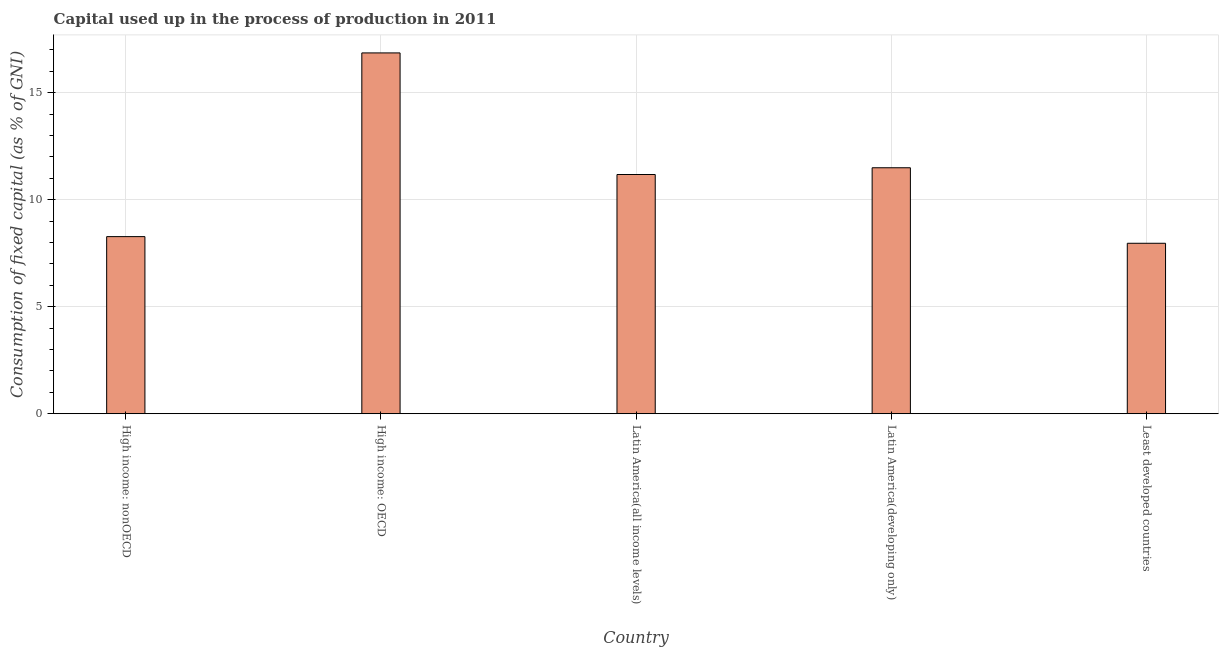Does the graph contain grids?
Ensure brevity in your answer.  Yes. What is the title of the graph?
Provide a succinct answer. Capital used up in the process of production in 2011. What is the label or title of the Y-axis?
Ensure brevity in your answer.  Consumption of fixed capital (as % of GNI). What is the consumption of fixed capital in High income: OECD?
Provide a succinct answer. 16.86. Across all countries, what is the maximum consumption of fixed capital?
Ensure brevity in your answer.  16.86. Across all countries, what is the minimum consumption of fixed capital?
Keep it short and to the point. 7.96. In which country was the consumption of fixed capital maximum?
Offer a terse response. High income: OECD. In which country was the consumption of fixed capital minimum?
Your answer should be very brief. Least developed countries. What is the sum of the consumption of fixed capital?
Your answer should be very brief. 55.77. What is the difference between the consumption of fixed capital in Latin America(all income levels) and Least developed countries?
Offer a very short reply. 3.21. What is the average consumption of fixed capital per country?
Offer a terse response. 11.15. What is the median consumption of fixed capital?
Ensure brevity in your answer.  11.18. What is the ratio of the consumption of fixed capital in High income: OECD to that in Latin America(all income levels)?
Give a very brief answer. 1.51. Is the consumption of fixed capital in High income: nonOECD less than that in Least developed countries?
Make the answer very short. No. Is the difference between the consumption of fixed capital in High income: nonOECD and Latin America(all income levels) greater than the difference between any two countries?
Provide a short and direct response. No. What is the difference between the highest and the second highest consumption of fixed capital?
Your response must be concise. 5.37. What is the difference between the highest and the lowest consumption of fixed capital?
Offer a terse response. 8.89. Are the values on the major ticks of Y-axis written in scientific E-notation?
Give a very brief answer. No. What is the Consumption of fixed capital (as % of GNI) of High income: nonOECD?
Offer a terse response. 8.28. What is the Consumption of fixed capital (as % of GNI) in High income: OECD?
Ensure brevity in your answer.  16.86. What is the Consumption of fixed capital (as % of GNI) in Latin America(all income levels)?
Offer a terse response. 11.18. What is the Consumption of fixed capital (as % of GNI) of Latin America(developing only)?
Offer a terse response. 11.49. What is the Consumption of fixed capital (as % of GNI) of Least developed countries?
Your response must be concise. 7.96. What is the difference between the Consumption of fixed capital (as % of GNI) in High income: nonOECD and High income: OECD?
Provide a short and direct response. -8.58. What is the difference between the Consumption of fixed capital (as % of GNI) in High income: nonOECD and Latin America(all income levels)?
Your answer should be compact. -2.9. What is the difference between the Consumption of fixed capital (as % of GNI) in High income: nonOECD and Latin America(developing only)?
Make the answer very short. -3.22. What is the difference between the Consumption of fixed capital (as % of GNI) in High income: nonOECD and Least developed countries?
Your response must be concise. 0.31. What is the difference between the Consumption of fixed capital (as % of GNI) in High income: OECD and Latin America(all income levels)?
Offer a very short reply. 5.68. What is the difference between the Consumption of fixed capital (as % of GNI) in High income: OECD and Latin America(developing only)?
Make the answer very short. 5.37. What is the difference between the Consumption of fixed capital (as % of GNI) in High income: OECD and Least developed countries?
Offer a very short reply. 8.89. What is the difference between the Consumption of fixed capital (as % of GNI) in Latin America(all income levels) and Latin America(developing only)?
Provide a short and direct response. -0.32. What is the difference between the Consumption of fixed capital (as % of GNI) in Latin America(all income levels) and Least developed countries?
Give a very brief answer. 3.21. What is the difference between the Consumption of fixed capital (as % of GNI) in Latin America(developing only) and Least developed countries?
Your answer should be compact. 3.53. What is the ratio of the Consumption of fixed capital (as % of GNI) in High income: nonOECD to that in High income: OECD?
Provide a succinct answer. 0.49. What is the ratio of the Consumption of fixed capital (as % of GNI) in High income: nonOECD to that in Latin America(all income levels)?
Provide a succinct answer. 0.74. What is the ratio of the Consumption of fixed capital (as % of GNI) in High income: nonOECD to that in Latin America(developing only)?
Give a very brief answer. 0.72. What is the ratio of the Consumption of fixed capital (as % of GNI) in High income: nonOECD to that in Least developed countries?
Your answer should be compact. 1.04. What is the ratio of the Consumption of fixed capital (as % of GNI) in High income: OECD to that in Latin America(all income levels)?
Keep it short and to the point. 1.51. What is the ratio of the Consumption of fixed capital (as % of GNI) in High income: OECD to that in Latin America(developing only)?
Keep it short and to the point. 1.47. What is the ratio of the Consumption of fixed capital (as % of GNI) in High income: OECD to that in Least developed countries?
Your answer should be compact. 2.12. What is the ratio of the Consumption of fixed capital (as % of GNI) in Latin America(all income levels) to that in Latin America(developing only)?
Ensure brevity in your answer.  0.97. What is the ratio of the Consumption of fixed capital (as % of GNI) in Latin America(all income levels) to that in Least developed countries?
Offer a very short reply. 1.4. What is the ratio of the Consumption of fixed capital (as % of GNI) in Latin America(developing only) to that in Least developed countries?
Your answer should be very brief. 1.44. 